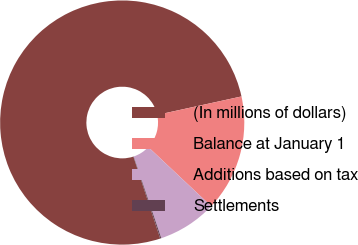Convert chart. <chart><loc_0><loc_0><loc_500><loc_500><pie_chart><fcel>(In millions of dollars)<fcel>Balance at January 1<fcel>Additions based on tax<fcel>Settlements<nl><fcel>76.61%<fcel>15.44%<fcel>7.8%<fcel>0.15%<nl></chart> 